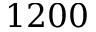Convert formula to latex. <formula><loc_0><loc_0><loc_500><loc_500>1 2 0 0</formula> 